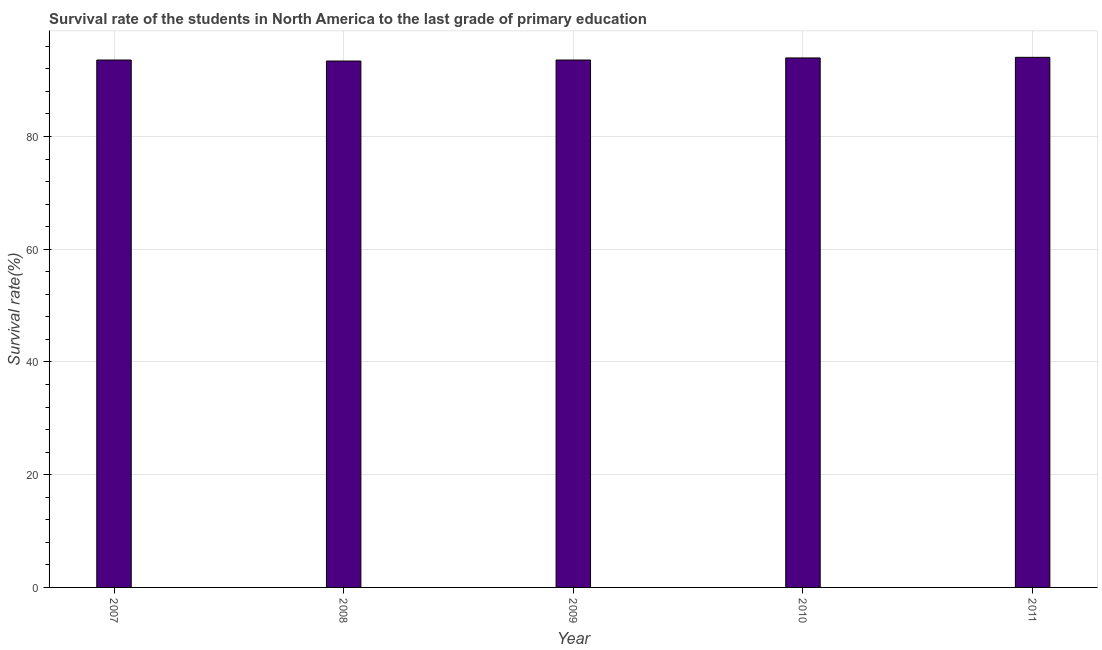Does the graph contain any zero values?
Provide a short and direct response. No. What is the title of the graph?
Provide a succinct answer. Survival rate of the students in North America to the last grade of primary education. What is the label or title of the Y-axis?
Ensure brevity in your answer.  Survival rate(%). What is the survival rate in primary education in 2008?
Your response must be concise. 93.39. Across all years, what is the maximum survival rate in primary education?
Ensure brevity in your answer.  94.04. Across all years, what is the minimum survival rate in primary education?
Give a very brief answer. 93.39. In which year was the survival rate in primary education maximum?
Your answer should be very brief. 2011. In which year was the survival rate in primary education minimum?
Keep it short and to the point. 2008. What is the sum of the survival rate in primary education?
Your answer should be very brief. 468.49. What is the difference between the survival rate in primary education in 2008 and 2010?
Your answer should be very brief. -0.55. What is the average survival rate in primary education per year?
Give a very brief answer. 93.7. What is the median survival rate in primary education?
Make the answer very short. 93.56. In how many years, is the survival rate in primary education greater than 88 %?
Offer a very short reply. 5. Do a majority of the years between 2009 and 2011 (inclusive) have survival rate in primary education greater than 48 %?
Provide a short and direct response. Yes. Is the survival rate in primary education in 2007 less than that in 2008?
Provide a succinct answer. No. What is the difference between the highest and the second highest survival rate in primary education?
Offer a very short reply. 0.11. What is the difference between the highest and the lowest survival rate in primary education?
Keep it short and to the point. 0.66. In how many years, is the survival rate in primary education greater than the average survival rate in primary education taken over all years?
Provide a short and direct response. 2. How many bars are there?
Keep it short and to the point. 5. Are all the bars in the graph horizontal?
Your response must be concise. No. How many years are there in the graph?
Your answer should be very brief. 5. Are the values on the major ticks of Y-axis written in scientific E-notation?
Your answer should be very brief. No. What is the Survival rate(%) of 2007?
Provide a succinct answer. 93.56. What is the Survival rate(%) of 2008?
Keep it short and to the point. 93.39. What is the Survival rate(%) of 2009?
Provide a succinct answer. 93.56. What is the Survival rate(%) of 2010?
Make the answer very short. 93.93. What is the Survival rate(%) in 2011?
Offer a very short reply. 94.04. What is the difference between the Survival rate(%) in 2007 and 2008?
Provide a succinct answer. 0.18. What is the difference between the Survival rate(%) in 2007 and 2009?
Offer a terse response. 3e-5. What is the difference between the Survival rate(%) in 2007 and 2010?
Provide a succinct answer. -0.37. What is the difference between the Survival rate(%) in 2007 and 2011?
Make the answer very short. -0.48. What is the difference between the Survival rate(%) in 2008 and 2009?
Your answer should be compact. -0.18. What is the difference between the Survival rate(%) in 2008 and 2010?
Provide a succinct answer. -0.55. What is the difference between the Survival rate(%) in 2008 and 2011?
Your answer should be compact. -0.66. What is the difference between the Survival rate(%) in 2009 and 2010?
Keep it short and to the point. -0.37. What is the difference between the Survival rate(%) in 2009 and 2011?
Your response must be concise. -0.48. What is the difference between the Survival rate(%) in 2010 and 2011?
Offer a very short reply. -0.11. What is the ratio of the Survival rate(%) in 2007 to that in 2008?
Provide a succinct answer. 1. What is the ratio of the Survival rate(%) in 2007 to that in 2009?
Offer a terse response. 1. What is the ratio of the Survival rate(%) in 2007 to that in 2010?
Make the answer very short. 1. What is the ratio of the Survival rate(%) in 2007 to that in 2011?
Keep it short and to the point. 0.99. What is the ratio of the Survival rate(%) in 2008 to that in 2009?
Offer a terse response. 1. What is the ratio of the Survival rate(%) in 2008 to that in 2011?
Provide a short and direct response. 0.99. What is the ratio of the Survival rate(%) in 2010 to that in 2011?
Provide a succinct answer. 1. 